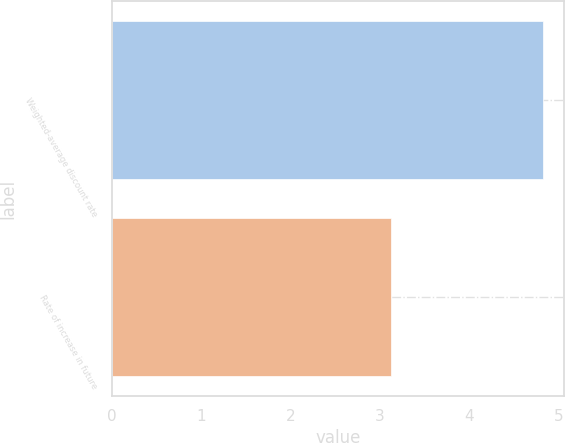<chart> <loc_0><loc_0><loc_500><loc_500><bar_chart><fcel>Weighted-average discount rate<fcel>Rate of increase in future<nl><fcel>4.82<fcel>3.12<nl></chart> 